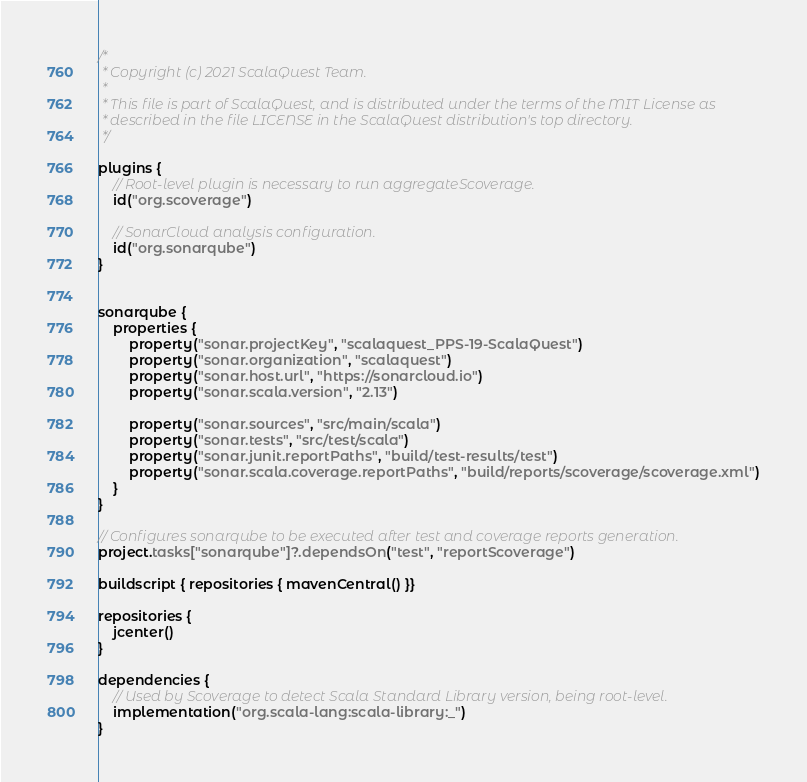Convert code to text. <code><loc_0><loc_0><loc_500><loc_500><_Kotlin_>/*
 * Copyright (c) 2021 ScalaQuest Team.
 *
 * This file is part of ScalaQuest, and is distributed under the terms of the MIT License as
 * described in the file LICENSE in the ScalaQuest distribution's top directory.
 */

plugins {
    // Root-level plugin is necessary to run aggregateScoverage.
    id("org.scoverage")

    // SonarCloud analysis configuration.
    id("org.sonarqube")
}


sonarqube {
    properties {
        property("sonar.projectKey", "scalaquest_PPS-19-ScalaQuest")
        property("sonar.organization", "scalaquest")
        property("sonar.host.url", "https://sonarcloud.io")
        property("sonar.scala.version", "2.13")

        property("sonar.sources", "src/main/scala")
        property("sonar.tests", "src/test/scala")
        property("sonar.junit.reportPaths", "build/test-results/test")
        property("sonar.scala.coverage.reportPaths", "build/reports/scoverage/scoverage.xml")
    }
}

// Configures sonarqube to be executed after test and coverage reports generation.
project.tasks["sonarqube"]?.dependsOn("test", "reportScoverage")

buildscript { repositories { mavenCentral() }}

repositories {
    jcenter()
}

dependencies {
    // Used by Scoverage to detect Scala Standard Library version, being root-level.
    implementation("org.scala-lang:scala-library:_")
}</code> 